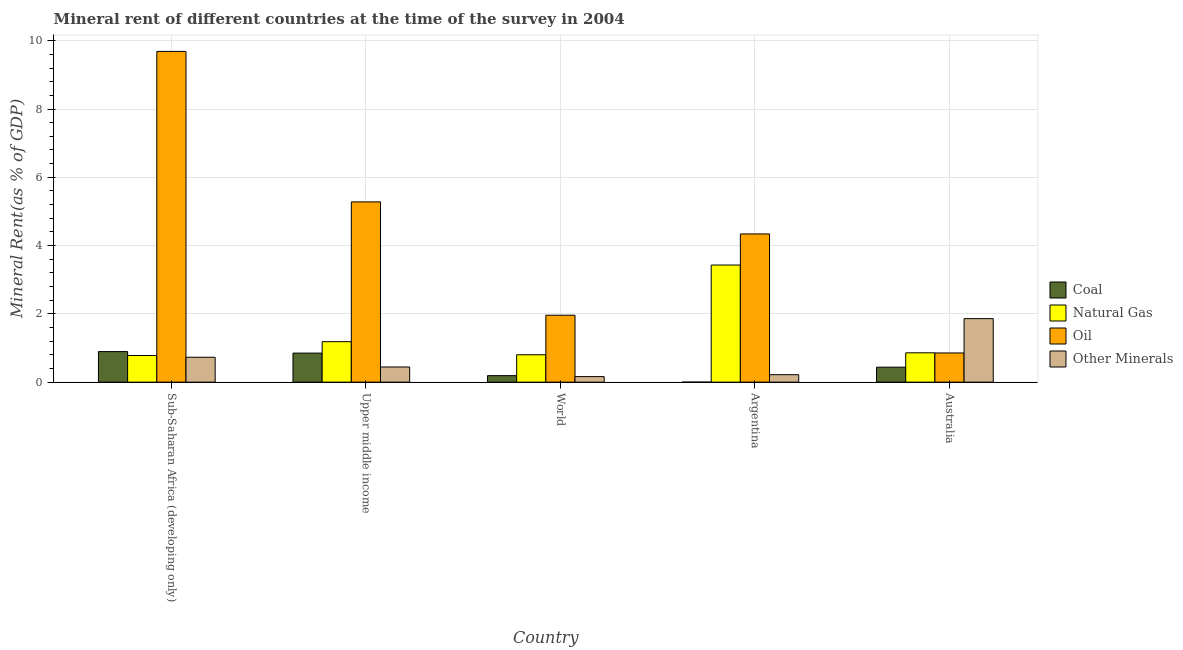How many different coloured bars are there?
Give a very brief answer. 4. Are the number of bars per tick equal to the number of legend labels?
Your response must be concise. Yes. Are the number of bars on each tick of the X-axis equal?
Give a very brief answer. Yes. What is the label of the 3rd group of bars from the left?
Ensure brevity in your answer.  World. In how many cases, is the number of bars for a given country not equal to the number of legend labels?
Keep it short and to the point. 0. What is the  rent of other minerals in World?
Your response must be concise. 0.16. Across all countries, what is the maximum natural gas rent?
Your answer should be very brief. 3.43. Across all countries, what is the minimum  rent of other minerals?
Keep it short and to the point. 0.16. In which country was the natural gas rent maximum?
Keep it short and to the point. Argentina. In which country was the  rent of other minerals minimum?
Offer a very short reply. World. What is the total natural gas rent in the graph?
Provide a succinct answer. 7.06. What is the difference between the  rent of other minerals in Australia and that in Sub-Saharan Africa (developing only)?
Keep it short and to the point. 1.13. What is the difference between the oil rent in Sub-Saharan Africa (developing only) and the  rent of other minerals in World?
Make the answer very short. 9.53. What is the average  rent of other minerals per country?
Ensure brevity in your answer.  0.68. What is the difference between the coal rent and  rent of other minerals in Australia?
Provide a succinct answer. -1.42. In how many countries, is the coal rent greater than 1.2000000000000002 %?
Provide a short and direct response. 0. What is the ratio of the oil rent in Australia to that in Sub-Saharan Africa (developing only)?
Ensure brevity in your answer.  0.09. Is the natural gas rent in Sub-Saharan Africa (developing only) less than that in Upper middle income?
Offer a terse response. Yes. What is the difference between the highest and the second highest  rent of other minerals?
Your response must be concise. 1.13. What is the difference between the highest and the lowest coal rent?
Your answer should be very brief. 0.89. Is it the case that in every country, the sum of the oil rent and coal rent is greater than the sum of natural gas rent and  rent of other minerals?
Make the answer very short. No. What does the 4th bar from the left in World represents?
Give a very brief answer. Other Minerals. What does the 2nd bar from the right in Upper middle income represents?
Offer a very short reply. Oil. Are all the bars in the graph horizontal?
Provide a short and direct response. No. What is the difference between two consecutive major ticks on the Y-axis?
Offer a very short reply. 2. Are the values on the major ticks of Y-axis written in scientific E-notation?
Offer a terse response. No. Does the graph contain any zero values?
Offer a very short reply. No. How are the legend labels stacked?
Your answer should be compact. Vertical. What is the title of the graph?
Provide a short and direct response. Mineral rent of different countries at the time of the survey in 2004. What is the label or title of the X-axis?
Keep it short and to the point. Country. What is the label or title of the Y-axis?
Offer a terse response. Mineral Rent(as % of GDP). What is the Mineral Rent(as % of GDP) in Coal in Sub-Saharan Africa (developing only)?
Ensure brevity in your answer.  0.9. What is the Mineral Rent(as % of GDP) of Natural Gas in Sub-Saharan Africa (developing only)?
Keep it short and to the point. 0.78. What is the Mineral Rent(as % of GDP) of Oil in Sub-Saharan Africa (developing only)?
Your answer should be very brief. 9.69. What is the Mineral Rent(as % of GDP) in Other Minerals in Sub-Saharan Africa (developing only)?
Provide a succinct answer. 0.73. What is the Mineral Rent(as % of GDP) of Coal in Upper middle income?
Provide a succinct answer. 0.85. What is the Mineral Rent(as % of GDP) of Natural Gas in Upper middle income?
Offer a terse response. 1.19. What is the Mineral Rent(as % of GDP) of Oil in Upper middle income?
Ensure brevity in your answer.  5.28. What is the Mineral Rent(as % of GDP) in Other Minerals in Upper middle income?
Make the answer very short. 0.44. What is the Mineral Rent(as % of GDP) in Coal in World?
Keep it short and to the point. 0.19. What is the Mineral Rent(as % of GDP) in Natural Gas in World?
Ensure brevity in your answer.  0.8. What is the Mineral Rent(as % of GDP) in Oil in World?
Your response must be concise. 1.96. What is the Mineral Rent(as % of GDP) of Other Minerals in World?
Keep it short and to the point. 0.16. What is the Mineral Rent(as % of GDP) of Coal in Argentina?
Give a very brief answer. 0. What is the Mineral Rent(as % of GDP) in Natural Gas in Argentina?
Keep it short and to the point. 3.43. What is the Mineral Rent(as % of GDP) of Oil in Argentina?
Your answer should be compact. 4.34. What is the Mineral Rent(as % of GDP) of Other Minerals in Argentina?
Offer a terse response. 0.22. What is the Mineral Rent(as % of GDP) in Coal in Australia?
Your answer should be compact. 0.44. What is the Mineral Rent(as % of GDP) in Natural Gas in Australia?
Offer a terse response. 0.86. What is the Mineral Rent(as % of GDP) in Oil in Australia?
Offer a terse response. 0.85. What is the Mineral Rent(as % of GDP) in Other Minerals in Australia?
Offer a terse response. 1.86. Across all countries, what is the maximum Mineral Rent(as % of GDP) of Coal?
Provide a succinct answer. 0.9. Across all countries, what is the maximum Mineral Rent(as % of GDP) in Natural Gas?
Give a very brief answer. 3.43. Across all countries, what is the maximum Mineral Rent(as % of GDP) in Oil?
Ensure brevity in your answer.  9.69. Across all countries, what is the maximum Mineral Rent(as % of GDP) in Other Minerals?
Keep it short and to the point. 1.86. Across all countries, what is the minimum Mineral Rent(as % of GDP) of Coal?
Provide a short and direct response. 0. Across all countries, what is the minimum Mineral Rent(as % of GDP) in Natural Gas?
Offer a very short reply. 0.78. Across all countries, what is the minimum Mineral Rent(as % of GDP) in Oil?
Provide a short and direct response. 0.85. Across all countries, what is the minimum Mineral Rent(as % of GDP) in Other Minerals?
Offer a very short reply. 0.16. What is the total Mineral Rent(as % of GDP) in Coal in the graph?
Your answer should be very brief. 2.37. What is the total Mineral Rent(as % of GDP) of Natural Gas in the graph?
Give a very brief answer. 7.06. What is the total Mineral Rent(as % of GDP) in Oil in the graph?
Give a very brief answer. 22.12. What is the total Mineral Rent(as % of GDP) of Other Minerals in the graph?
Offer a terse response. 3.41. What is the difference between the Mineral Rent(as % of GDP) in Coal in Sub-Saharan Africa (developing only) and that in Upper middle income?
Make the answer very short. 0.04. What is the difference between the Mineral Rent(as % of GDP) of Natural Gas in Sub-Saharan Africa (developing only) and that in Upper middle income?
Ensure brevity in your answer.  -0.4. What is the difference between the Mineral Rent(as % of GDP) in Oil in Sub-Saharan Africa (developing only) and that in Upper middle income?
Make the answer very short. 4.41. What is the difference between the Mineral Rent(as % of GDP) of Other Minerals in Sub-Saharan Africa (developing only) and that in Upper middle income?
Your answer should be very brief. 0.29. What is the difference between the Mineral Rent(as % of GDP) in Coal in Sub-Saharan Africa (developing only) and that in World?
Give a very brief answer. 0.7. What is the difference between the Mineral Rent(as % of GDP) in Natural Gas in Sub-Saharan Africa (developing only) and that in World?
Offer a very short reply. -0.02. What is the difference between the Mineral Rent(as % of GDP) of Oil in Sub-Saharan Africa (developing only) and that in World?
Make the answer very short. 7.73. What is the difference between the Mineral Rent(as % of GDP) in Other Minerals in Sub-Saharan Africa (developing only) and that in World?
Keep it short and to the point. 0.57. What is the difference between the Mineral Rent(as % of GDP) of Coal in Sub-Saharan Africa (developing only) and that in Argentina?
Provide a short and direct response. 0.89. What is the difference between the Mineral Rent(as % of GDP) of Natural Gas in Sub-Saharan Africa (developing only) and that in Argentina?
Your answer should be very brief. -2.65. What is the difference between the Mineral Rent(as % of GDP) in Oil in Sub-Saharan Africa (developing only) and that in Argentina?
Make the answer very short. 5.35. What is the difference between the Mineral Rent(as % of GDP) of Other Minerals in Sub-Saharan Africa (developing only) and that in Argentina?
Offer a terse response. 0.51. What is the difference between the Mineral Rent(as % of GDP) in Coal in Sub-Saharan Africa (developing only) and that in Australia?
Give a very brief answer. 0.46. What is the difference between the Mineral Rent(as % of GDP) of Natural Gas in Sub-Saharan Africa (developing only) and that in Australia?
Provide a short and direct response. -0.08. What is the difference between the Mineral Rent(as % of GDP) in Oil in Sub-Saharan Africa (developing only) and that in Australia?
Provide a succinct answer. 8.83. What is the difference between the Mineral Rent(as % of GDP) of Other Minerals in Sub-Saharan Africa (developing only) and that in Australia?
Your answer should be very brief. -1.13. What is the difference between the Mineral Rent(as % of GDP) in Coal in Upper middle income and that in World?
Your response must be concise. 0.66. What is the difference between the Mineral Rent(as % of GDP) in Natural Gas in Upper middle income and that in World?
Give a very brief answer. 0.38. What is the difference between the Mineral Rent(as % of GDP) in Oil in Upper middle income and that in World?
Make the answer very short. 3.32. What is the difference between the Mineral Rent(as % of GDP) in Other Minerals in Upper middle income and that in World?
Provide a succinct answer. 0.28. What is the difference between the Mineral Rent(as % of GDP) in Coal in Upper middle income and that in Argentina?
Your response must be concise. 0.85. What is the difference between the Mineral Rent(as % of GDP) in Natural Gas in Upper middle income and that in Argentina?
Give a very brief answer. -2.24. What is the difference between the Mineral Rent(as % of GDP) in Oil in Upper middle income and that in Argentina?
Your answer should be compact. 0.94. What is the difference between the Mineral Rent(as % of GDP) of Other Minerals in Upper middle income and that in Argentina?
Offer a terse response. 0.23. What is the difference between the Mineral Rent(as % of GDP) in Coal in Upper middle income and that in Australia?
Provide a succinct answer. 0.41. What is the difference between the Mineral Rent(as % of GDP) of Natural Gas in Upper middle income and that in Australia?
Ensure brevity in your answer.  0.33. What is the difference between the Mineral Rent(as % of GDP) in Oil in Upper middle income and that in Australia?
Provide a short and direct response. 4.43. What is the difference between the Mineral Rent(as % of GDP) in Other Minerals in Upper middle income and that in Australia?
Keep it short and to the point. -1.42. What is the difference between the Mineral Rent(as % of GDP) in Coal in World and that in Argentina?
Offer a very short reply. 0.19. What is the difference between the Mineral Rent(as % of GDP) in Natural Gas in World and that in Argentina?
Keep it short and to the point. -2.63. What is the difference between the Mineral Rent(as % of GDP) of Oil in World and that in Argentina?
Your answer should be compact. -2.38. What is the difference between the Mineral Rent(as % of GDP) in Other Minerals in World and that in Argentina?
Give a very brief answer. -0.06. What is the difference between the Mineral Rent(as % of GDP) of Coal in World and that in Australia?
Your response must be concise. -0.25. What is the difference between the Mineral Rent(as % of GDP) of Natural Gas in World and that in Australia?
Keep it short and to the point. -0.06. What is the difference between the Mineral Rent(as % of GDP) of Oil in World and that in Australia?
Offer a terse response. 1.11. What is the difference between the Mineral Rent(as % of GDP) in Other Minerals in World and that in Australia?
Ensure brevity in your answer.  -1.7. What is the difference between the Mineral Rent(as % of GDP) of Coal in Argentina and that in Australia?
Your answer should be very brief. -0.44. What is the difference between the Mineral Rent(as % of GDP) in Natural Gas in Argentina and that in Australia?
Your response must be concise. 2.57. What is the difference between the Mineral Rent(as % of GDP) of Oil in Argentina and that in Australia?
Offer a very short reply. 3.49. What is the difference between the Mineral Rent(as % of GDP) of Other Minerals in Argentina and that in Australia?
Ensure brevity in your answer.  -1.64. What is the difference between the Mineral Rent(as % of GDP) in Coal in Sub-Saharan Africa (developing only) and the Mineral Rent(as % of GDP) in Natural Gas in Upper middle income?
Give a very brief answer. -0.29. What is the difference between the Mineral Rent(as % of GDP) in Coal in Sub-Saharan Africa (developing only) and the Mineral Rent(as % of GDP) in Oil in Upper middle income?
Your response must be concise. -4.39. What is the difference between the Mineral Rent(as % of GDP) in Coal in Sub-Saharan Africa (developing only) and the Mineral Rent(as % of GDP) in Other Minerals in Upper middle income?
Make the answer very short. 0.45. What is the difference between the Mineral Rent(as % of GDP) of Natural Gas in Sub-Saharan Africa (developing only) and the Mineral Rent(as % of GDP) of Oil in Upper middle income?
Your response must be concise. -4.5. What is the difference between the Mineral Rent(as % of GDP) in Natural Gas in Sub-Saharan Africa (developing only) and the Mineral Rent(as % of GDP) in Other Minerals in Upper middle income?
Offer a terse response. 0.34. What is the difference between the Mineral Rent(as % of GDP) of Oil in Sub-Saharan Africa (developing only) and the Mineral Rent(as % of GDP) of Other Minerals in Upper middle income?
Give a very brief answer. 9.24. What is the difference between the Mineral Rent(as % of GDP) in Coal in Sub-Saharan Africa (developing only) and the Mineral Rent(as % of GDP) in Natural Gas in World?
Your response must be concise. 0.09. What is the difference between the Mineral Rent(as % of GDP) in Coal in Sub-Saharan Africa (developing only) and the Mineral Rent(as % of GDP) in Oil in World?
Ensure brevity in your answer.  -1.06. What is the difference between the Mineral Rent(as % of GDP) of Coal in Sub-Saharan Africa (developing only) and the Mineral Rent(as % of GDP) of Other Minerals in World?
Your answer should be compact. 0.73. What is the difference between the Mineral Rent(as % of GDP) in Natural Gas in Sub-Saharan Africa (developing only) and the Mineral Rent(as % of GDP) in Oil in World?
Offer a terse response. -1.18. What is the difference between the Mineral Rent(as % of GDP) of Natural Gas in Sub-Saharan Africa (developing only) and the Mineral Rent(as % of GDP) of Other Minerals in World?
Offer a very short reply. 0.62. What is the difference between the Mineral Rent(as % of GDP) in Oil in Sub-Saharan Africa (developing only) and the Mineral Rent(as % of GDP) in Other Minerals in World?
Keep it short and to the point. 9.53. What is the difference between the Mineral Rent(as % of GDP) in Coal in Sub-Saharan Africa (developing only) and the Mineral Rent(as % of GDP) in Natural Gas in Argentina?
Your answer should be very brief. -2.54. What is the difference between the Mineral Rent(as % of GDP) in Coal in Sub-Saharan Africa (developing only) and the Mineral Rent(as % of GDP) in Oil in Argentina?
Provide a succinct answer. -3.45. What is the difference between the Mineral Rent(as % of GDP) of Coal in Sub-Saharan Africa (developing only) and the Mineral Rent(as % of GDP) of Other Minerals in Argentina?
Keep it short and to the point. 0.68. What is the difference between the Mineral Rent(as % of GDP) in Natural Gas in Sub-Saharan Africa (developing only) and the Mineral Rent(as % of GDP) in Oil in Argentina?
Your response must be concise. -3.56. What is the difference between the Mineral Rent(as % of GDP) in Natural Gas in Sub-Saharan Africa (developing only) and the Mineral Rent(as % of GDP) in Other Minerals in Argentina?
Offer a very short reply. 0.56. What is the difference between the Mineral Rent(as % of GDP) of Oil in Sub-Saharan Africa (developing only) and the Mineral Rent(as % of GDP) of Other Minerals in Argentina?
Provide a short and direct response. 9.47. What is the difference between the Mineral Rent(as % of GDP) in Coal in Sub-Saharan Africa (developing only) and the Mineral Rent(as % of GDP) in Natural Gas in Australia?
Provide a succinct answer. 0.04. What is the difference between the Mineral Rent(as % of GDP) in Coal in Sub-Saharan Africa (developing only) and the Mineral Rent(as % of GDP) in Oil in Australia?
Give a very brief answer. 0.04. What is the difference between the Mineral Rent(as % of GDP) in Coal in Sub-Saharan Africa (developing only) and the Mineral Rent(as % of GDP) in Other Minerals in Australia?
Your response must be concise. -0.97. What is the difference between the Mineral Rent(as % of GDP) of Natural Gas in Sub-Saharan Africa (developing only) and the Mineral Rent(as % of GDP) of Oil in Australia?
Provide a short and direct response. -0.07. What is the difference between the Mineral Rent(as % of GDP) of Natural Gas in Sub-Saharan Africa (developing only) and the Mineral Rent(as % of GDP) of Other Minerals in Australia?
Provide a succinct answer. -1.08. What is the difference between the Mineral Rent(as % of GDP) of Oil in Sub-Saharan Africa (developing only) and the Mineral Rent(as % of GDP) of Other Minerals in Australia?
Your response must be concise. 7.83. What is the difference between the Mineral Rent(as % of GDP) of Coal in Upper middle income and the Mineral Rent(as % of GDP) of Natural Gas in World?
Offer a terse response. 0.05. What is the difference between the Mineral Rent(as % of GDP) in Coal in Upper middle income and the Mineral Rent(as % of GDP) in Oil in World?
Your response must be concise. -1.11. What is the difference between the Mineral Rent(as % of GDP) of Coal in Upper middle income and the Mineral Rent(as % of GDP) of Other Minerals in World?
Your answer should be compact. 0.69. What is the difference between the Mineral Rent(as % of GDP) of Natural Gas in Upper middle income and the Mineral Rent(as % of GDP) of Oil in World?
Make the answer very short. -0.77. What is the difference between the Mineral Rent(as % of GDP) of Natural Gas in Upper middle income and the Mineral Rent(as % of GDP) of Other Minerals in World?
Offer a very short reply. 1.02. What is the difference between the Mineral Rent(as % of GDP) in Oil in Upper middle income and the Mineral Rent(as % of GDP) in Other Minerals in World?
Your answer should be very brief. 5.12. What is the difference between the Mineral Rent(as % of GDP) in Coal in Upper middle income and the Mineral Rent(as % of GDP) in Natural Gas in Argentina?
Your answer should be very brief. -2.58. What is the difference between the Mineral Rent(as % of GDP) in Coal in Upper middle income and the Mineral Rent(as % of GDP) in Oil in Argentina?
Your response must be concise. -3.49. What is the difference between the Mineral Rent(as % of GDP) in Coal in Upper middle income and the Mineral Rent(as % of GDP) in Other Minerals in Argentina?
Ensure brevity in your answer.  0.63. What is the difference between the Mineral Rent(as % of GDP) in Natural Gas in Upper middle income and the Mineral Rent(as % of GDP) in Oil in Argentina?
Keep it short and to the point. -3.16. What is the difference between the Mineral Rent(as % of GDP) in Natural Gas in Upper middle income and the Mineral Rent(as % of GDP) in Other Minerals in Argentina?
Keep it short and to the point. 0.97. What is the difference between the Mineral Rent(as % of GDP) of Oil in Upper middle income and the Mineral Rent(as % of GDP) of Other Minerals in Argentina?
Ensure brevity in your answer.  5.06. What is the difference between the Mineral Rent(as % of GDP) of Coal in Upper middle income and the Mineral Rent(as % of GDP) of Natural Gas in Australia?
Provide a succinct answer. -0.01. What is the difference between the Mineral Rent(as % of GDP) of Coal in Upper middle income and the Mineral Rent(as % of GDP) of Oil in Australia?
Your answer should be very brief. -0. What is the difference between the Mineral Rent(as % of GDP) in Coal in Upper middle income and the Mineral Rent(as % of GDP) in Other Minerals in Australia?
Give a very brief answer. -1.01. What is the difference between the Mineral Rent(as % of GDP) in Natural Gas in Upper middle income and the Mineral Rent(as % of GDP) in Oil in Australia?
Provide a short and direct response. 0.33. What is the difference between the Mineral Rent(as % of GDP) of Natural Gas in Upper middle income and the Mineral Rent(as % of GDP) of Other Minerals in Australia?
Keep it short and to the point. -0.68. What is the difference between the Mineral Rent(as % of GDP) in Oil in Upper middle income and the Mineral Rent(as % of GDP) in Other Minerals in Australia?
Make the answer very short. 3.42. What is the difference between the Mineral Rent(as % of GDP) in Coal in World and the Mineral Rent(as % of GDP) in Natural Gas in Argentina?
Your answer should be compact. -3.24. What is the difference between the Mineral Rent(as % of GDP) in Coal in World and the Mineral Rent(as % of GDP) in Oil in Argentina?
Provide a succinct answer. -4.15. What is the difference between the Mineral Rent(as % of GDP) in Coal in World and the Mineral Rent(as % of GDP) in Other Minerals in Argentina?
Ensure brevity in your answer.  -0.03. What is the difference between the Mineral Rent(as % of GDP) of Natural Gas in World and the Mineral Rent(as % of GDP) of Oil in Argentina?
Keep it short and to the point. -3.54. What is the difference between the Mineral Rent(as % of GDP) of Natural Gas in World and the Mineral Rent(as % of GDP) of Other Minerals in Argentina?
Keep it short and to the point. 0.58. What is the difference between the Mineral Rent(as % of GDP) of Oil in World and the Mineral Rent(as % of GDP) of Other Minerals in Argentina?
Make the answer very short. 1.74. What is the difference between the Mineral Rent(as % of GDP) in Coal in World and the Mineral Rent(as % of GDP) in Natural Gas in Australia?
Your answer should be compact. -0.67. What is the difference between the Mineral Rent(as % of GDP) in Coal in World and the Mineral Rent(as % of GDP) in Oil in Australia?
Your answer should be compact. -0.66. What is the difference between the Mineral Rent(as % of GDP) in Coal in World and the Mineral Rent(as % of GDP) in Other Minerals in Australia?
Offer a terse response. -1.67. What is the difference between the Mineral Rent(as % of GDP) in Natural Gas in World and the Mineral Rent(as % of GDP) in Oil in Australia?
Provide a succinct answer. -0.05. What is the difference between the Mineral Rent(as % of GDP) in Natural Gas in World and the Mineral Rent(as % of GDP) in Other Minerals in Australia?
Provide a short and direct response. -1.06. What is the difference between the Mineral Rent(as % of GDP) in Oil in World and the Mineral Rent(as % of GDP) in Other Minerals in Australia?
Offer a terse response. 0.1. What is the difference between the Mineral Rent(as % of GDP) in Coal in Argentina and the Mineral Rent(as % of GDP) in Natural Gas in Australia?
Ensure brevity in your answer.  -0.86. What is the difference between the Mineral Rent(as % of GDP) in Coal in Argentina and the Mineral Rent(as % of GDP) in Oil in Australia?
Offer a terse response. -0.85. What is the difference between the Mineral Rent(as % of GDP) in Coal in Argentina and the Mineral Rent(as % of GDP) in Other Minerals in Australia?
Provide a short and direct response. -1.86. What is the difference between the Mineral Rent(as % of GDP) of Natural Gas in Argentina and the Mineral Rent(as % of GDP) of Oil in Australia?
Your response must be concise. 2.58. What is the difference between the Mineral Rent(as % of GDP) of Natural Gas in Argentina and the Mineral Rent(as % of GDP) of Other Minerals in Australia?
Make the answer very short. 1.57. What is the difference between the Mineral Rent(as % of GDP) in Oil in Argentina and the Mineral Rent(as % of GDP) in Other Minerals in Australia?
Offer a terse response. 2.48. What is the average Mineral Rent(as % of GDP) of Coal per country?
Ensure brevity in your answer.  0.47. What is the average Mineral Rent(as % of GDP) in Natural Gas per country?
Your answer should be very brief. 1.41. What is the average Mineral Rent(as % of GDP) of Oil per country?
Ensure brevity in your answer.  4.42. What is the average Mineral Rent(as % of GDP) in Other Minerals per country?
Offer a very short reply. 0.68. What is the difference between the Mineral Rent(as % of GDP) in Coal and Mineral Rent(as % of GDP) in Natural Gas in Sub-Saharan Africa (developing only)?
Keep it short and to the point. 0.11. What is the difference between the Mineral Rent(as % of GDP) of Coal and Mineral Rent(as % of GDP) of Oil in Sub-Saharan Africa (developing only)?
Provide a succinct answer. -8.79. What is the difference between the Mineral Rent(as % of GDP) of Coal and Mineral Rent(as % of GDP) of Other Minerals in Sub-Saharan Africa (developing only)?
Your response must be concise. 0.17. What is the difference between the Mineral Rent(as % of GDP) in Natural Gas and Mineral Rent(as % of GDP) in Oil in Sub-Saharan Africa (developing only)?
Give a very brief answer. -8.91. What is the difference between the Mineral Rent(as % of GDP) in Natural Gas and Mineral Rent(as % of GDP) in Other Minerals in Sub-Saharan Africa (developing only)?
Your answer should be compact. 0.05. What is the difference between the Mineral Rent(as % of GDP) of Oil and Mineral Rent(as % of GDP) of Other Minerals in Sub-Saharan Africa (developing only)?
Keep it short and to the point. 8.96. What is the difference between the Mineral Rent(as % of GDP) in Coal and Mineral Rent(as % of GDP) in Natural Gas in Upper middle income?
Ensure brevity in your answer.  -0.33. What is the difference between the Mineral Rent(as % of GDP) in Coal and Mineral Rent(as % of GDP) in Oil in Upper middle income?
Offer a very short reply. -4.43. What is the difference between the Mineral Rent(as % of GDP) of Coal and Mineral Rent(as % of GDP) of Other Minerals in Upper middle income?
Keep it short and to the point. 0.41. What is the difference between the Mineral Rent(as % of GDP) of Natural Gas and Mineral Rent(as % of GDP) of Oil in Upper middle income?
Provide a succinct answer. -4.09. What is the difference between the Mineral Rent(as % of GDP) of Natural Gas and Mineral Rent(as % of GDP) of Other Minerals in Upper middle income?
Ensure brevity in your answer.  0.74. What is the difference between the Mineral Rent(as % of GDP) in Oil and Mineral Rent(as % of GDP) in Other Minerals in Upper middle income?
Ensure brevity in your answer.  4.84. What is the difference between the Mineral Rent(as % of GDP) in Coal and Mineral Rent(as % of GDP) in Natural Gas in World?
Ensure brevity in your answer.  -0.61. What is the difference between the Mineral Rent(as % of GDP) in Coal and Mineral Rent(as % of GDP) in Oil in World?
Your answer should be compact. -1.77. What is the difference between the Mineral Rent(as % of GDP) in Coal and Mineral Rent(as % of GDP) in Other Minerals in World?
Provide a short and direct response. 0.03. What is the difference between the Mineral Rent(as % of GDP) of Natural Gas and Mineral Rent(as % of GDP) of Oil in World?
Provide a succinct answer. -1.16. What is the difference between the Mineral Rent(as % of GDP) in Natural Gas and Mineral Rent(as % of GDP) in Other Minerals in World?
Give a very brief answer. 0.64. What is the difference between the Mineral Rent(as % of GDP) of Oil and Mineral Rent(as % of GDP) of Other Minerals in World?
Your answer should be very brief. 1.8. What is the difference between the Mineral Rent(as % of GDP) of Coal and Mineral Rent(as % of GDP) of Natural Gas in Argentina?
Your answer should be very brief. -3.43. What is the difference between the Mineral Rent(as % of GDP) in Coal and Mineral Rent(as % of GDP) in Oil in Argentina?
Ensure brevity in your answer.  -4.34. What is the difference between the Mineral Rent(as % of GDP) of Coal and Mineral Rent(as % of GDP) of Other Minerals in Argentina?
Make the answer very short. -0.22. What is the difference between the Mineral Rent(as % of GDP) in Natural Gas and Mineral Rent(as % of GDP) in Oil in Argentina?
Offer a terse response. -0.91. What is the difference between the Mineral Rent(as % of GDP) in Natural Gas and Mineral Rent(as % of GDP) in Other Minerals in Argentina?
Your answer should be very brief. 3.21. What is the difference between the Mineral Rent(as % of GDP) of Oil and Mineral Rent(as % of GDP) of Other Minerals in Argentina?
Your answer should be very brief. 4.12. What is the difference between the Mineral Rent(as % of GDP) of Coal and Mineral Rent(as % of GDP) of Natural Gas in Australia?
Offer a very short reply. -0.42. What is the difference between the Mineral Rent(as % of GDP) of Coal and Mineral Rent(as % of GDP) of Oil in Australia?
Ensure brevity in your answer.  -0.42. What is the difference between the Mineral Rent(as % of GDP) of Coal and Mineral Rent(as % of GDP) of Other Minerals in Australia?
Offer a very short reply. -1.42. What is the difference between the Mineral Rent(as % of GDP) in Natural Gas and Mineral Rent(as % of GDP) in Oil in Australia?
Your response must be concise. 0. What is the difference between the Mineral Rent(as % of GDP) in Natural Gas and Mineral Rent(as % of GDP) in Other Minerals in Australia?
Provide a succinct answer. -1. What is the difference between the Mineral Rent(as % of GDP) of Oil and Mineral Rent(as % of GDP) of Other Minerals in Australia?
Keep it short and to the point. -1.01. What is the ratio of the Mineral Rent(as % of GDP) in Coal in Sub-Saharan Africa (developing only) to that in Upper middle income?
Keep it short and to the point. 1.05. What is the ratio of the Mineral Rent(as % of GDP) of Natural Gas in Sub-Saharan Africa (developing only) to that in Upper middle income?
Offer a very short reply. 0.66. What is the ratio of the Mineral Rent(as % of GDP) of Oil in Sub-Saharan Africa (developing only) to that in Upper middle income?
Keep it short and to the point. 1.83. What is the ratio of the Mineral Rent(as % of GDP) in Other Minerals in Sub-Saharan Africa (developing only) to that in Upper middle income?
Make the answer very short. 1.64. What is the ratio of the Mineral Rent(as % of GDP) of Coal in Sub-Saharan Africa (developing only) to that in World?
Offer a terse response. 4.7. What is the ratio of the Mineral Rent(as % of GDP) of Natural Gas in Sub-Saharan Africa (developing only) to that in World?
Provide a short and direct response. 0.97. What is the ratio of the Mineral Rent(as % of GDP) of Oil in Sub-Saharan Africa (developing only) to that in World?
Your answer should be very brief. 4.94. What is the ratio of the Mineral Rent(as % of GDP) of Other Minerals in Sub-Saharan Africa (developing only) to that in World?
Your response must be concise. 4.51. What is the ratio of the Mineral Rent(as % of GDP) in Coal in Sub-Saharan Africa (developing only) to that in Argentina?
Offer a very short reply. 3019.66. What is the ratio of the Mineral Rent(as % of GDP) in Natural Gas in Sub-Saharan Africa (developing only) to that in Argentina?
Keep it short and to the point. 0.23. What is the ratio of the Mineral Rent(as % of GDP) in Oil in Sub-Saharan Africa (developing only) to that in Argentina?
Make the answer very short. 2.23. What is the ratio of the Mineral Rent(as % of GDP) of Other Minerals in Sub-Saharan Africa (developing only) to that in Argentina?
Your answer should be very brief. 3.34. What is the ratio of the Mineral Rent(as % of GDP) of Coal in Sub-Saharan Africa (developing only) to that in Australia?
Your response must be concise. 2.04. What is the ratio of the Mineral Rent(as % of GDP) of Natural Gas in Sub-Saharan Africa (developing only) to that in Australia?
Give a very brief answer. 0.91. What is the ratio of the Mineral Rent(as % of GDP) in Oil in Sub-Saharan Africa (developing only) to that in Australia?
Your answer should be compact. 11.33. What is the ratio of the Mineral Rent(as % of GDP) of Other Minerals in Sub-Saharan Africa (developing only) to that in Australia?
Give a very brief answer. 0.39. What is the ratio of the Mineral Rent(as % of GDP) in Coal in Upper middle income to that in World?
Keep it short and to the point. 4.46. What is the ratio of the Mineral Rent(as % of GDP) of Natural Gas in Upper middle income to that in World?
Ensure brevity in your answer.  1.48. What is the ratio of the Mineral Rent(as % of GDP) in Oil in Upper middle income to that in World?
Make the answer very short. 2.69. What is the ratio of the Mineral Rent(as % of GDP) of Other Minerals in Upper middle income to that in World?
Your answer should be compact. 2.74. What is the ratio of the Mineral Rent(as % of GDP) of Coal in Upper middle income to that in Argentina?
Offer a terse response. 2870.18. What is the ratio of the Mineral Rent(as % of GDP) in Natural Gas in Upper middle income to that in Argentina?
Provide a succinct answer. 0.35. What is the ratio of the Mineral Rent(as % of GDP) in Oil in Upper middle income to that in Argentina?
Offer a very short reply. 1.22. What is the ratio of the Mineral Rent(as % of GDP) in Other Minerals in Upper middle income to that in Argentina?
Offer a terse response. 2.03. What is the ratio of the Mineral Rent(as % of GDP) in Coal in Upper middle income to that in Australia?
Your answer should be very brief. 1.94. What is the ratio of the Mineral Rent(as % of GDP) of Natural Gas in Upper middle income to that in Australia?
Your response must be concise. 1.38. What is the ratio of the Mineral Rent(as % of GDP) in Oil in Upper middle income to that in Australia?
Your answer should be very brief. 6.18. What is the ratio of the Mineral Rent(as % of GDP) of Other Minerals in Upper middle income to that in Australia?
Provide a succinct answer. 0.24. What is the ratio of the Mineral Rent(as % of GDP) in Coal in World to that in Argentina?
Provide a succinct answer. 642.87. What is the ratio of the Mineral Rent(as % of GDP) in Natural Gas in World to that in Argentina?
Provide a short and direct response. 0.23. What is the ratio of the Mineral Rent(as % of GDP) in Oil in World to that in Argentina?
Your response must be concise. 0.45. What is the ratio of the Mineral Rent(as % of GDP) of Other Minerals in World to that in Argentina?
Your answer should be very brief. 0.74. What is the ratio of the Mineral Rent(as % of GDP) of Coal in World to that in Australia?
Offer a terse response. 0.43. What is the ratio of the Mineral Rent(as % of GDP) of Oil in World to that in Australia?
Offer a very short reply. 2.29. What is the ratio of the Mineral Rent(as % of GDP) in Other Minerals in World to that in Australia?
Your answer should be compact. 0.09. What is the ratio of the Mineral Rent(as % of GDP) in Coal in Argentina to that in Australia?
Provide a short and direct response. 0. What is the ratio of the Mineral Rent(as % of GDP) in Natural Gas in Argentina to that in Australia?
Your answer should be compact. 3.99. What is the ratio of the Mineral Rent(as % of GDP) of Oil in Argentina to that in Australia?
Ensure brevity in your answer.  5.08. What is the ratio of the Mineral Rent(as % of GDP) of Other Minerals in Argentina to that in Australia?
Offer a very short reply. 0.12. What is the difference between the highest and the second highest Mineral Rent(as % of GDP) of Coal?
Give a very brief answer. 0.04. What is the difference between the highest and the second highest Mineral Rent(as % of GDP) of Natural Gas?
Make the answer very short. 2.24. What is the difference between the highest and the second highest Mineral Rent(as % of GDP) in Oil?
Provide a succinct answer. 4.41. What is the difference between the highest and the second highest Mineral Rent(as % of GDP) in Other Minerals?
Provide a short and direct response. 1.13. What is the difference between the highest and the lowest Mineral Rent(as % of GDP) in Coal?
Give a very brief answer. 0.89. What is the difference between the highest and the lowest Mineral Rent(as % of GDP) in Natural Gas?
Offer a terse response. 2.65. What is the difference between the highest and the lowest Mineral Rent(as % of GDP) in Oil?
Your answer should be compact. 8.83. What is the difference between the highest and the lowest Mineral Rent(as % of GDP) in Other Minerals?
Provide a short and direct response. 1.7. 